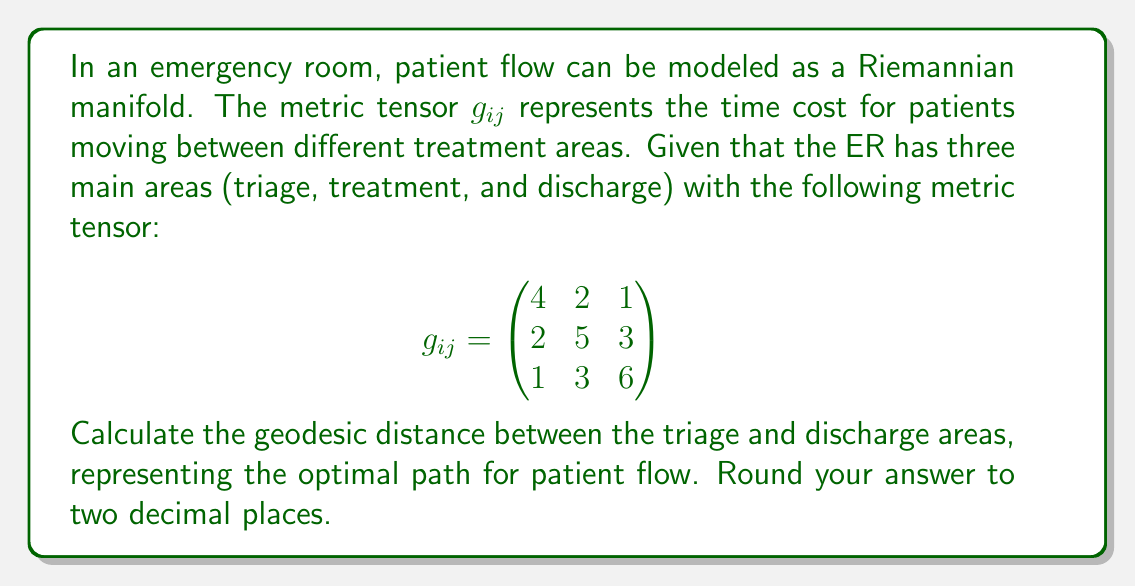Could you help me with this problem? To find the geodesic distance between two points on a Riemannian manifold, we need to solve the geodesic equation. However, for a simple 3-dimensional manifold, we can use the fact that the geodesic distance is given by the arc length of the shortest path between two points.

The arc length in Riemannian geometry is given by:

$$s = \int_{0}^{1} \sqrt{g_{ij}\frac{dx^i}{dt}\frac{dx^j}{dt}} dt$$

For our case, we're interested in the path from triage (point 1) to discharge (point 3). The shortest path in this simple case is a straight line, which can be parameterized as:

$$x^1(t) = 1-t, \quad x^2(t) = 0, \quad x^3(t) = t$$

Where $t$ goes from 0 to 1.

Substituting into the arc length formula:

$$s = \int_{0}^{1} \sqrt{g_{11}(-1)^2 + 2g_{13}(-1)(1) + g_{33}(1)^2} dt$$

$$s = \int_{0}^{1} \sqrt{g_{11} - 2g_{13} + g_{33}} dt$$

Now, substituting the values from our metric tensor:

$$s = \int_{0}^{1} \sqrt{4 - 2(1) + 6} dt = \int_{0}^{1} \sqrt{9} dt = 3 \int_{0}^{1} dt = 3$$

Therefore, the geodesic distance between triage and discharge is 3 units.
Answer: 3.00 